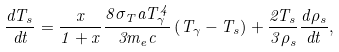Convert formula to latex. <formula><loc_0><loc_0><loc_500><loc_500>\frac { d T _ { s } } { d t } = \frac { x } { 1 + x } \frac { 8 \sigma _ { T } a T _ { \gamma } ^ { 4 } } { 3 m _ { e } c } \left ( T _ { \gamma } - T _ { s } \right ) + \frac { 2 T _ { s } } { 3 \rho _ { s } } \frac { d \rho _ { s } } { d t } ,</formula> 